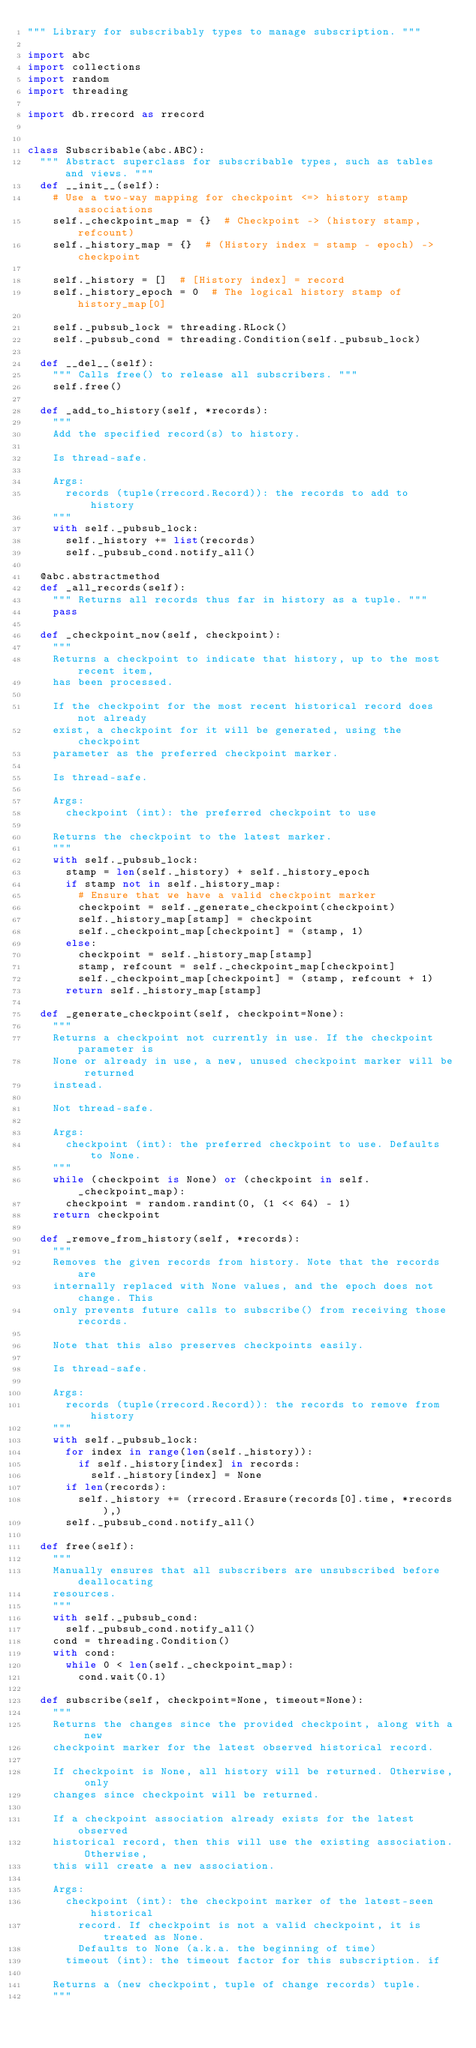<code> <loc_0><loc_0><loc_500><loc_500><_Python_>""" Library for subscribably types to manage subscription. """

import abc
import collections
import random
import threading

import db.rrecord as rrecord


class Subscribable(abc.ABC):
  """ Abstract superclass for subscribable types, such as tables and views. """
  def __init__(self):
    # Use a two-way mapping for checkpoint <=> history stamp associations
    self._checkpoint_map = {}  # Checkpoint -> (history stamp, refcount)
    self._history_map = {}  # (History index = stamp - epoch) -> checkpoint

    self._history = []  # [History index] = record
    self._history_epoch = 0  # The logical history stamp of history_map[0]

    self._pubsub_lock = threading.RLock()
    self._pubsub_cond = threading.Condition(self._pubsub_lock)

  def __del__(self):
    """ Calls free() to release all subscribers. """
    self.free()

  def _add_to_history(self, *records):
    """
    Add the specified record(s) to history.

    Is thread-safe.

    Args:
      records (tuple(rrecord.Record)): the records to add to history
    """
    with self._pubsub_lock:
      self._history += list(records)
      self._pubsub_cond.notify_all()

  @abc.abstractmethod
  def _all_records(self):
    """ Returns all records thus far in history as a tuple. """
    pass

  def _checkpoint_now(self, checkpoint):
    """
    Returns a checkpoint to indicate that history, up to the most recent item,
    has been processed.

    If the checkpoint for the most recent historical record does not already
    exist, a checkpoint for it will be generated, using the checkpoint
    parameter as the preferred checkpoint marker.

    Is thread-safe.

    Args:
      checkpoint (int): the preferred checkpoint to use

    Returns the checkpoint to the latest marker.
    """
    with self._pubsub_lock:
      stamp = len(self._history) + self._history_epoch
      if stamp not in self._history_map:
        # Ensure that we have a valid checkpoint marker
        checkpoint = self._generate_checkpoint(checkpoint)
        self._history_map[stamp] = checkpoint
        self._checkpoint_map[checkpoint] = (stamp, 1)
      else:
        checkpoint = self._history_map[stamp]
        stamp, refcount = self._checkpoint_map[checkpoint]
        self._checkpoint_map[checkpoint] = (stamp, refcount + 1)
      return self._history_map[stamp]

  def _generate_checkpoint(self, checkpoint=None):
    """
    Returns a checkpoint not currently in use. If the checkpoint parameter is
    None or already in use, a new, unused checkpoint marker will be returned
    instead.

    Not thread-safe.

    Args:
      checkpoint (int): the preferred checkpoint to use. Defaults to None.
    """
    while (checkpoint is None) or (checkpoint in self._checkpoint_map):
      checkpoint = random.randint(0, (1 << 64) - 1)
    return checkpoint

  def _remove_from_history(self, *records):
    """
    Removes the given records from history. Note that the records are
    internally replaced with None values, and the epoch does not change. This
    only prevents future calls to subscribe() from receiving those records.

    Note that this also preserves checkpoints easily.

    Is thread-safe.

    Args:
      records (tuple(rrecord.Record)): the records to remove from history
    """
    with self._pubsub_lock:
      for index in range(len(self._history)):
        if self._history[index] in records:
          self._history[index] = None
      if len(records):
        self._history += (rrecord.Erasure(records[0].time, *records),)
      self._pubsub_cond.notify_all()

  def free(self):
    """
    Manually ensures that all subscribers are unsubscribed before deallocating
    resources.
    """
    with self._pubsub_cond:
      self._pubsub_cond.notify_all()
    cond = threading.Condition()
    with cond:
      while 0 < len(self._checkpoint_map):
        cond.wait(0.1)

  def subscribe(self, checkpoint=None, timeout=None):
    """
    Returns the changes since the provided checkpoint, along with a new
    checkpoint marker for the latest observed historical record.

    If checkpoint is None, all history will be returned. Otherwise, only
    changes since checkpoint will be returned.

    If a checkpoint association already exists for the latest observed
    historical record, then this will use the existing association. Otherwise,
    this will create a new association.

    Args:
      checkpoint (int): the checkpoint marker of the latest-seen historical
        record. If checkpoint is not a valid checkpoint, it is treated as None.
        Defaults to None (a.k.a. the beginning of time)
      timeout (int): the timeout factor for this subscription. if 

    Returns a (new checkpoint, tuple of change records) tuple.
    """</code> 